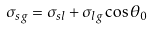Convert formula to latex. <formula><loc_0><loc_0><loc_500><loc_500>\sigma _ { s g } = \sigma _ { s l } + \sigma _ { l g } \cos \theta _ { 0 }</formula> 